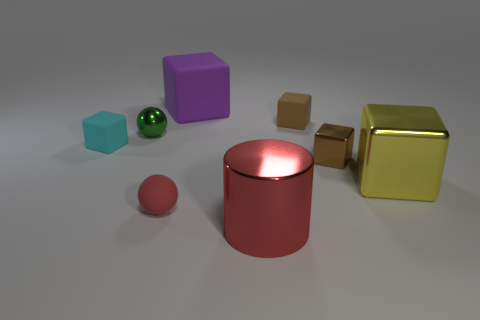Subtract 1 cubes. How many cubes are left? 4 Subtract all green cubes. Subtract all green cylinders. How many cubes are left? 5 Add 1 red metal balls. How many objects exist? 9 Subtract all cylinders. How many objects are left? 7 Subtract 0 green cubes. How many objects are left? 8 Subtract all large shiny cubes. Subtract all green spheres. How many objects are left? 6 Add 6 tiny brown rubber cubes. How many tiny brown rubber cubes are left? 7 Add 8 small matte spheres. How many small matte spheres exist? 9 